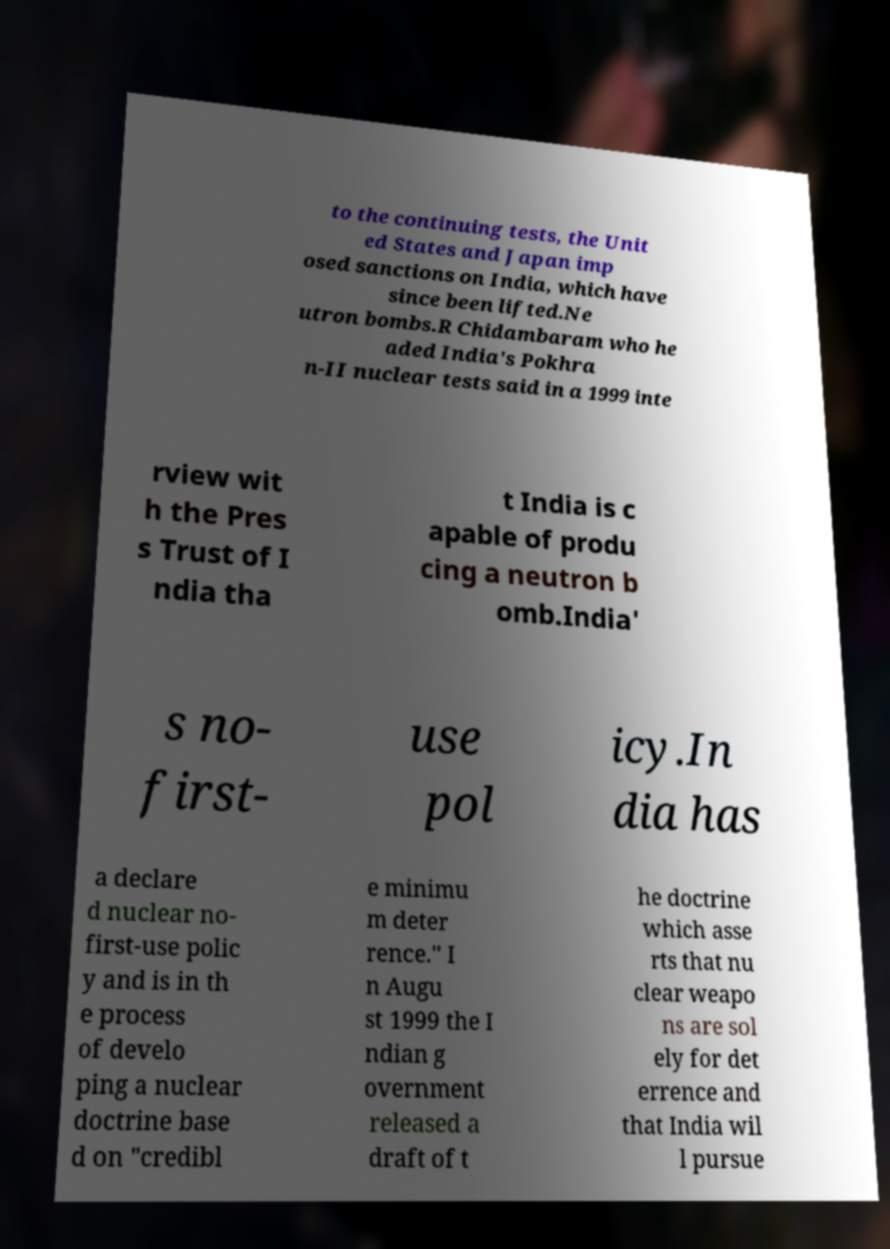What messages or text are displayed in this image? I need them in a readable, typed format. to the continuing tests, the Unit ed States and Japan imp osed sanctions on India, which have since been lifted.Ne utron bombs.R Chidambaram who he aded India's Pokhra n-II nuclear tests said in a 1999 inte rview wit h the Pres s Trust of I ndia tha t India is c apable of produ cing a neutron b omb.India' s no- first- use pol icy.In dia has a declare d nuclear no- first-use polic y and is in th e process of develo ping a nuclear doctrine base d on "credibl e minimu m deter rence." I n Augu st 1999 the I ndian g overnment released a draft of t he doctrine which asse rts that nu clear weapo ns are sol ely for det errence and that India wil l pursue 